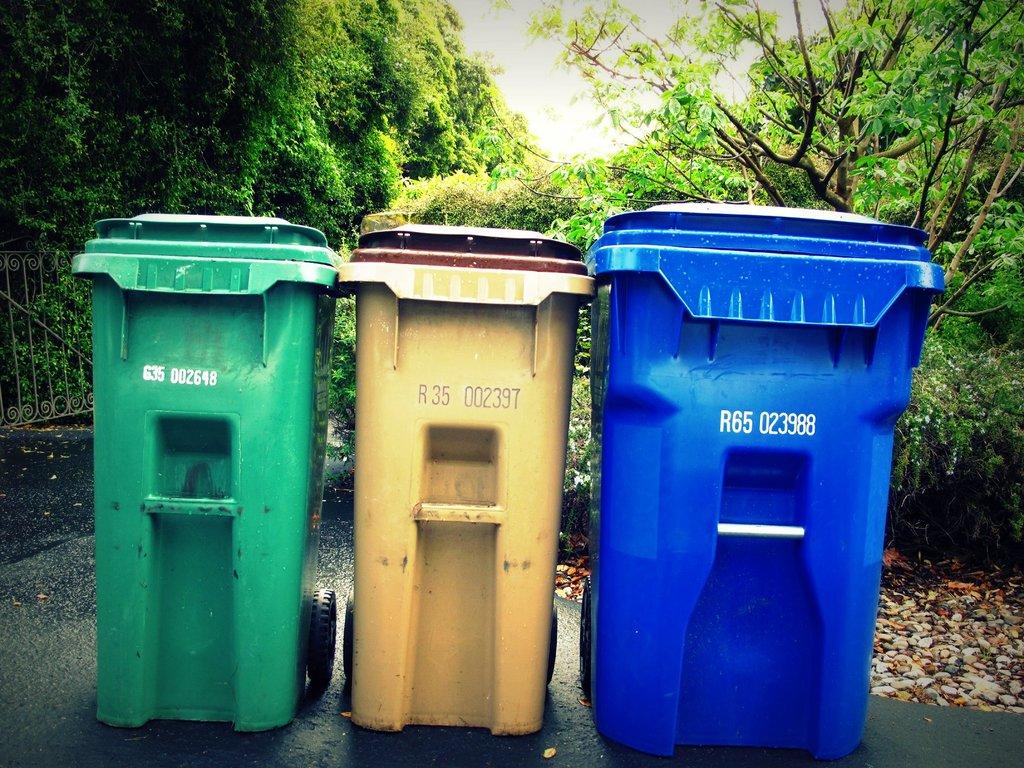What is the number of the blue bin?
Keep it short and to the point. R65 023988. What is the number of the yellow bin?
Provide a succinct answer. R35 002397. 